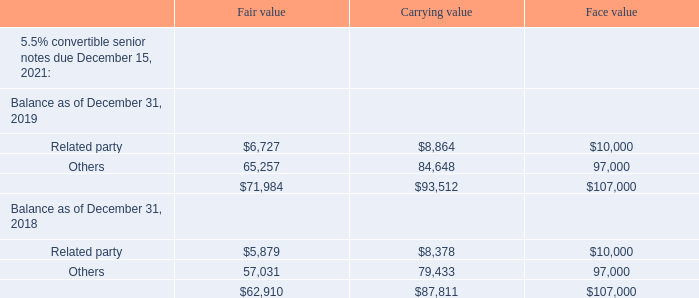Fair Value of Convertible Notes held at amortized cost
As of December 31, 2019 and 2018, the fair value and carrying value of the Company's Convertible Notes were:
The fair value shown above represents the fair value of the debt instrument, inclusive of both the debt and equity components, but excluding the derivative liability. The carrying value represents only the carrying value of the debt component.
The fair value of the Convertible Notes was determined by using unobservable inputs that are supported by minimal non-active market activity and that are significant to determining the fair value of the debt instrument. The fair value is level 3 in the fair value hierarchy.
(Dollars in thousands, except per share amounts)
What is the fair value of related party 5.5% convertible senior notes due December 15, 2021 as of December 31, 2019?
Answer scale should be: thousand. $6,727. What is the carrying value of related party 5.5% convertible senior notes due December 15, 2021 as of December 31, 2019?
Answer scale should be: thousand. $8,864. What is the face value of related party 5.5% convertible senior notes due December 15, 2021 as of December 31, 2019?
Answer scale should be: thousand. $10,000. What is the average fair value of related party and other 5.5% convertible senior notes due December 15, 2021 in 2019?
Answer scale should be: thousand. (6,727 + 65,257)/2 
Answer: 35992. What is the percentage change in the fair value of related party 5.5% convertible senior notes due December 15, 2021 between 2018 and 2019?
Answer scale should be: percent. (6,727 - 5,879)/5,879 
Answer: 14.42. What is the total fair value of related party 5.5% convertible senior notes due December 15, 2021 in 2018 and 2019?
Answer scale should be: thousand. 6,727 + 5,879 
Answer: 12606. 